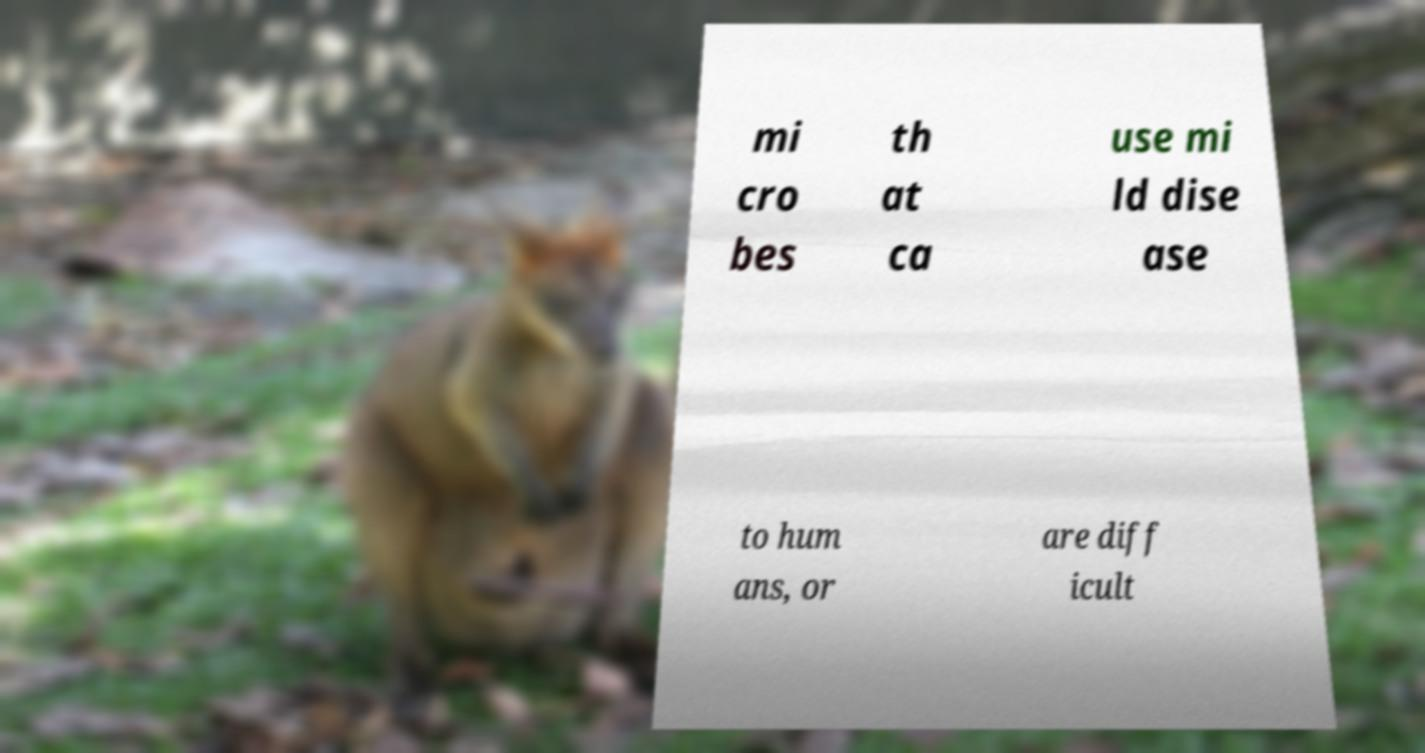Could you extract and type out the text from this image? mi cro bes th at ca use mi ld dise ase to hum ans, or are diff icult 